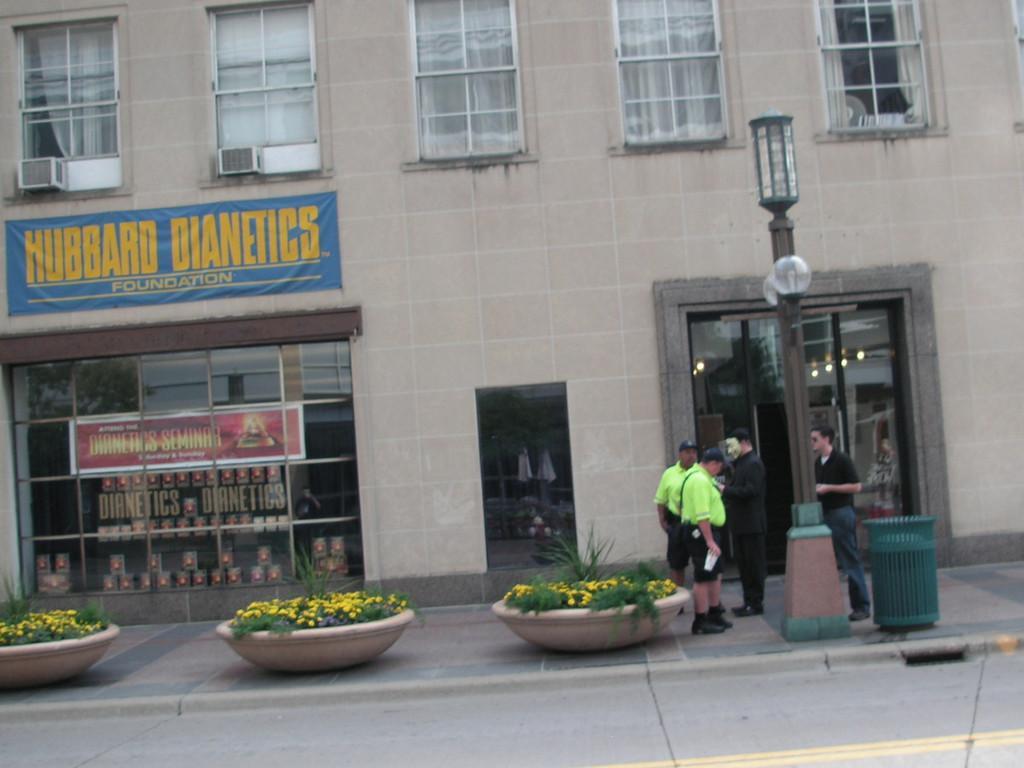Please provide a concise description of this image. This is a picture taken from outside city on the street. In the foreground of the picture, on the footpath there are flower pots, flowers, people, dustbin and street light. In the background there are windows, doors, banner and a building. 